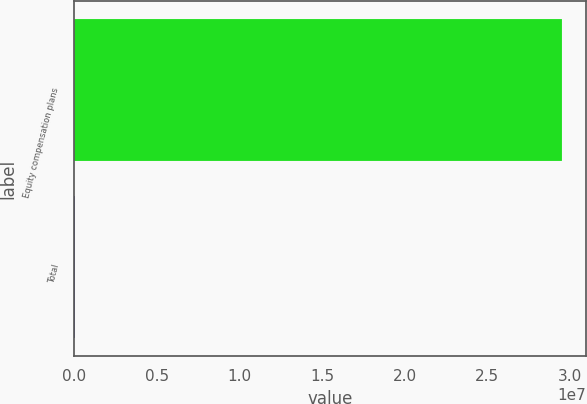<chart> <loc_0><loc_0><loc_500><loc_500><bar_chart><fcel>Equity compensation plans<fcel>Total<nl><fcel>2.95356e+07<fcel>29535.6<nl></chart> 